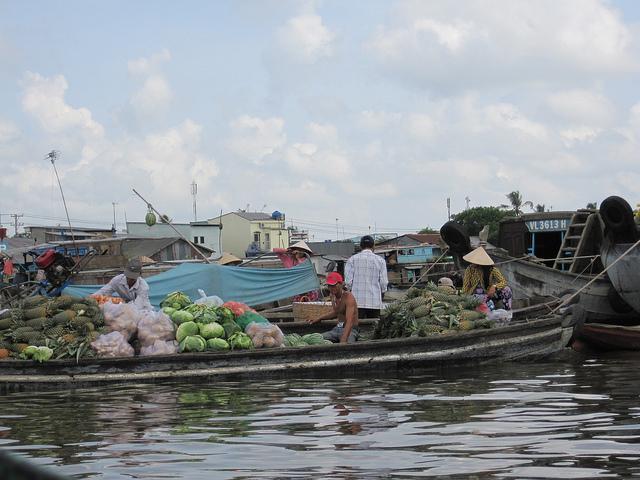How many men are pulling someone out of the water?
Give a very brief answer. 0. How many people are on the boat?
Give a very brief answer. 3. How many boats can be seen?
Give a very brief answer. 3. How many baby giraffes are in the picture?
Give a very brief answer. 0. 